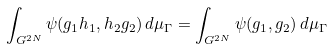Convert formula to latex. <formula><loc_0><loc_0><loc_500><loc_500>\int _ { G ^ { 2 N } } \psi ( g _ { 1 } h _ { 1 } , h _ { 2 } g _ { 2 } ) \, d \mu _ { \Gamma } = \int _ { G ^ { 2 N } } \psi ( g _ { 1 } , g _ { 2 } ) \, d \mu _ { \Gamma }</formula> 